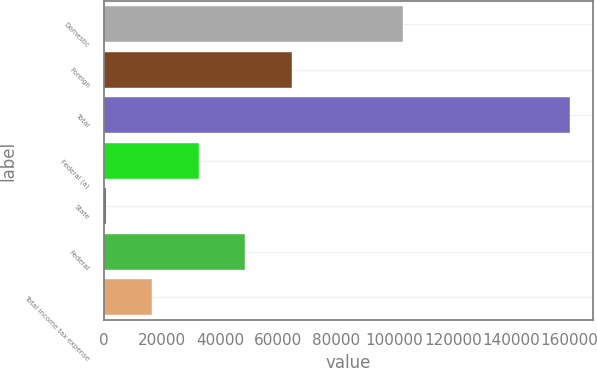<chart> <loc_0><loc_0><loc_500><loc_500><bar_chart><fcel>Domestic<fcel>Foreign<fcel>Total<fcel>Federal (a)<fcel>State<fcel>Federal<fcel>Total income tax expense<nl><fcel>103050<fcel>64572.4<fcel>160273<fcel>32672.2<fcel>772<fcel>48622.3<fcel>16722.1<nl></chart> 